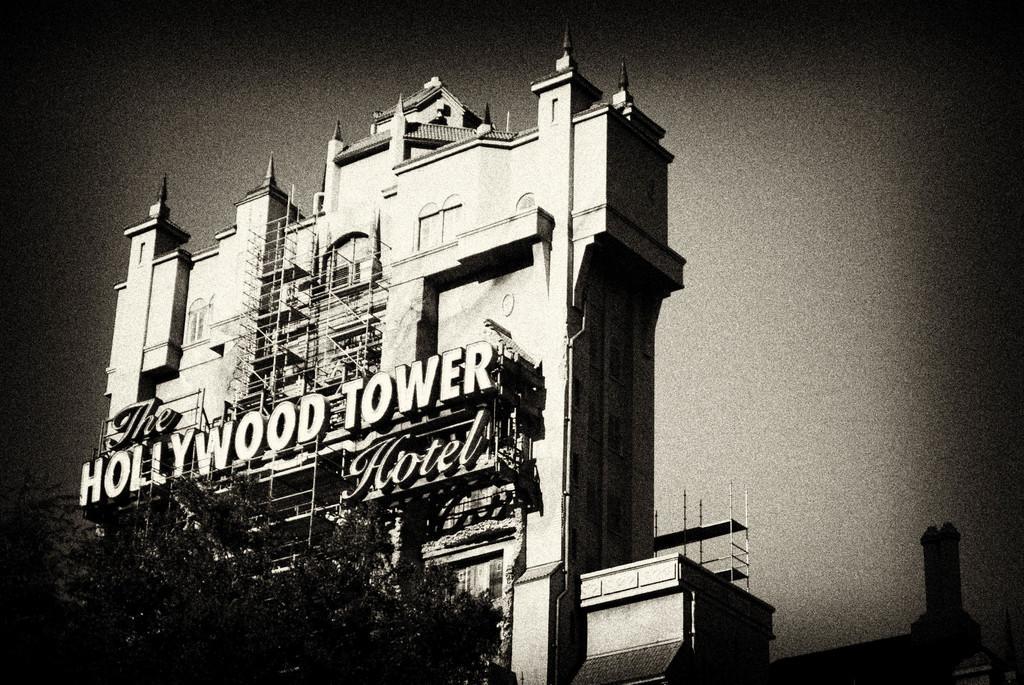Can you describe this image briefly? In this image I can see a building and few trees, and the image is in black and white. 